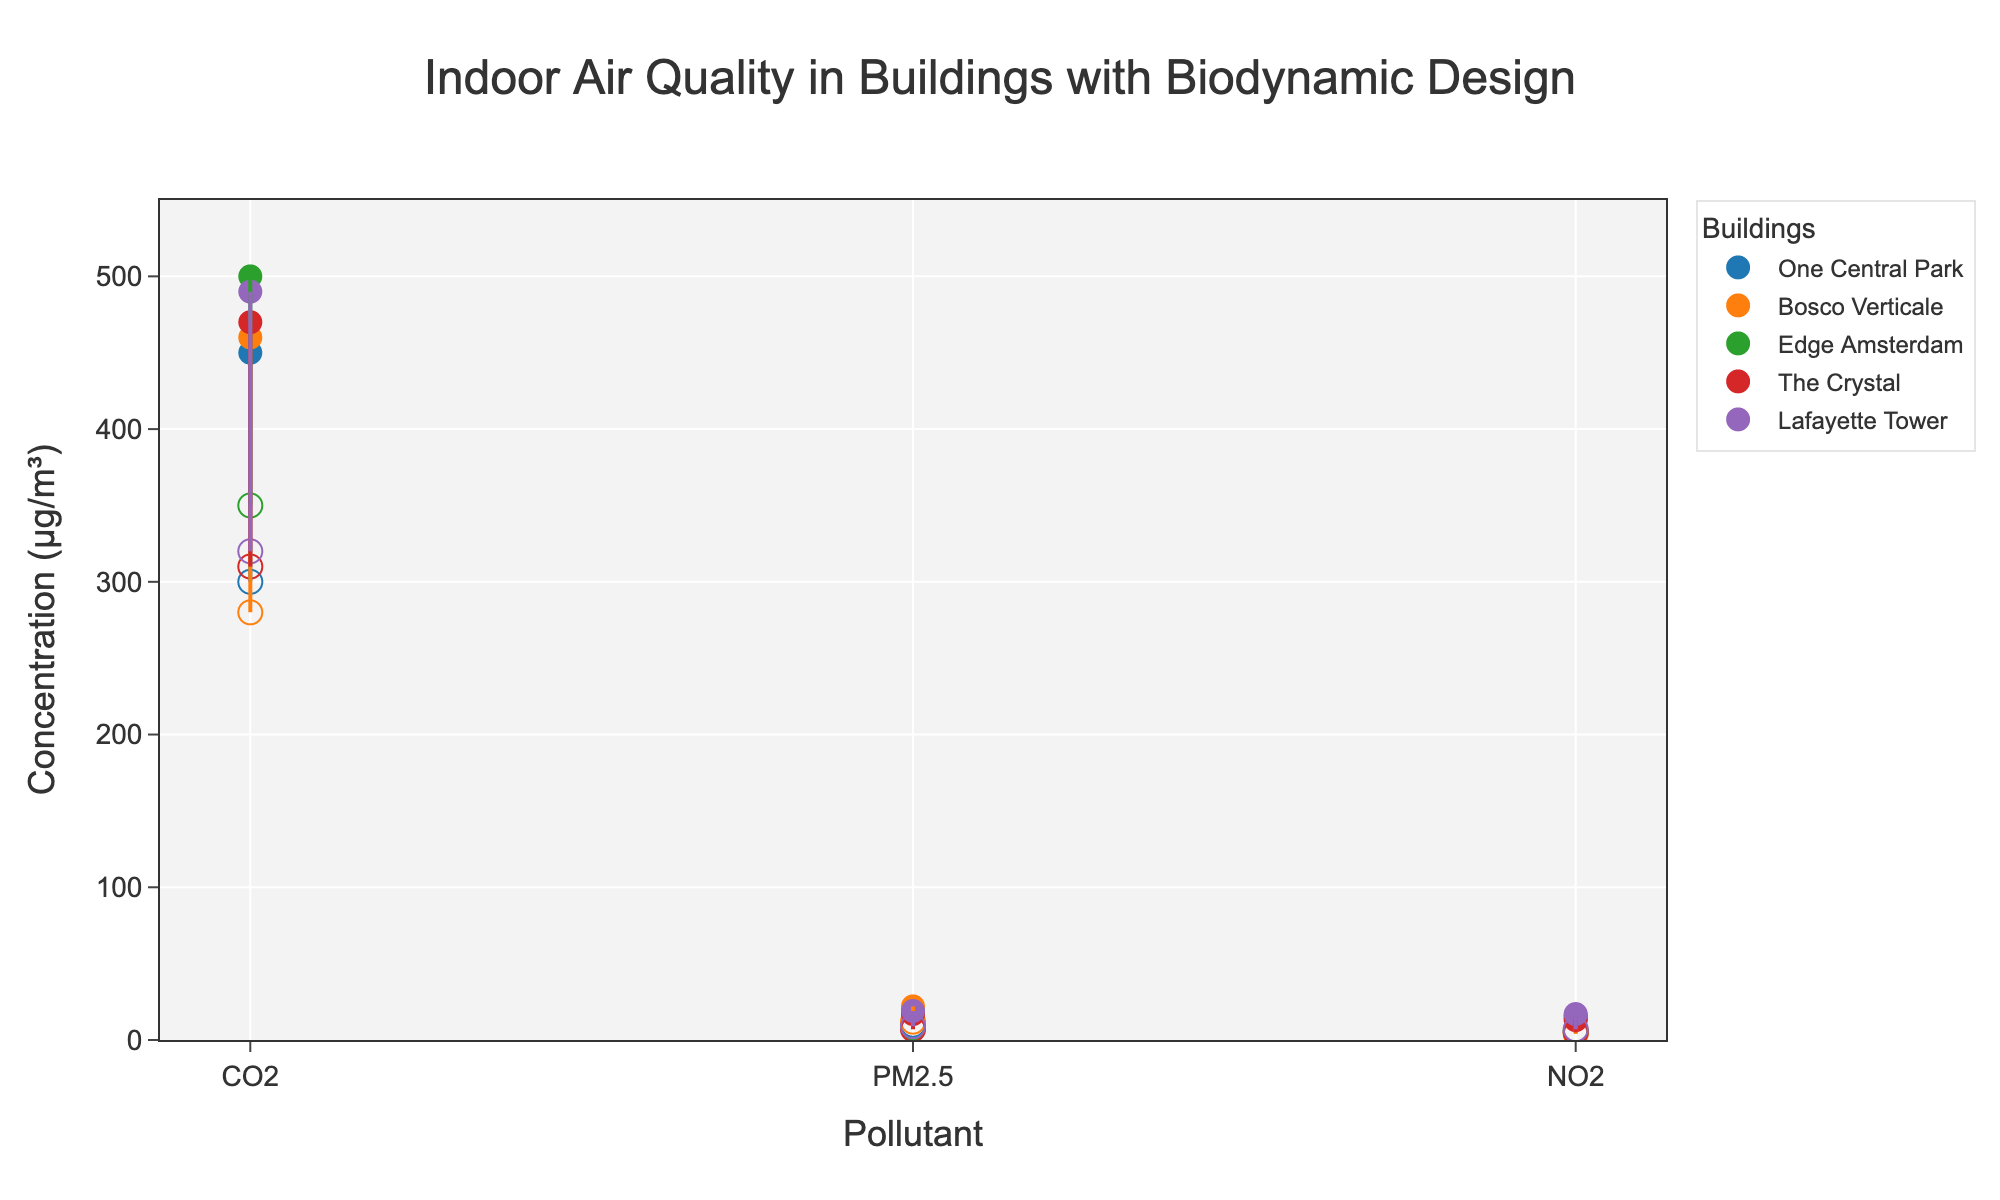What is the title of the plot? The title is displayed at the top of the figure and provides an overview of the content being shown.
Answer: Indoor Air Quality in Buildings with Biodynamic Design What pollutant has the highest maximum concentration across all buildings? By visually examining the dots representing the maximum concentrations, we see that CO2 has the highest concentration compared to PM2.5 and NO2 across all buildings.
Answer: CO2 Which building has the lowest minimum concentration of NO2? To find this, we look at the lowest point for NO2 among all buildings. It's the point closest to the bottom along the y-axis for NO2.
Answer: Bosco Verticale What is the range of PM2.5 concentrations in Edge Amsterdam? The range is calculated by subtracting the minimum concentration from the maximum concentration for PM2.5 in Edge Amsterdam. The min is 8 µg/m³, and the max is 18 µg/m³, so 18 - 8 = 10.
Answer: 10 µg/m³ Compare the maximum concentrations of CO2 between One Central Park and Lafayette Tower. Which building has a higher value? By comparing the maximum concentration dots for CO2 for these two buildings, it is clear that Lafayette Tower (490 µg/m³) is higher than One Central Park (450 µg/m³).
Answer: Lafayette Tower Which pollutant in The Crystal has the smallest variation in concentration? The smallest variation is found by looking for the shortest line representing the concentration range in The Crystal. PM2.5 ranges from 7 to 17, NO2 from 5 to 13, and CO2 from 310 to 470, so PM2.5 has the smallest range.
Answer: PM2.5 What are the minimum and maximum concentrations of CO2 in Bosco Verticale? The min and max CO2 concentrations for Bosco Verticale are read directly off the respective points on the plot. Min is 280 µg/m³ and Max is 460 µg/m³.
Answer: 280 µg/m³, 460 µg/m³ Which building has the largest range of concentrations for any pollutant? Examining the longest line for any pollutant across all buildings, Edge Amsterdam for CO2 appears to have a line ranging from 350 to 500 µg/m³, giving it the largest range of 150 µg/m³.
Answer: Edge Amsterdam 